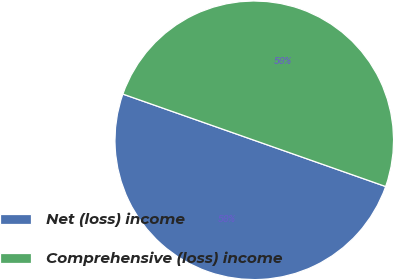Convert chart to OTSL. <chart><loc_0><loc_0><loc_500><loc_500><pie_chart><fcel>Net (loss) income<fcel>Comprehensive (loss) income<nl><fcel>50.0%<fcel>50.0%<nl></chart> 